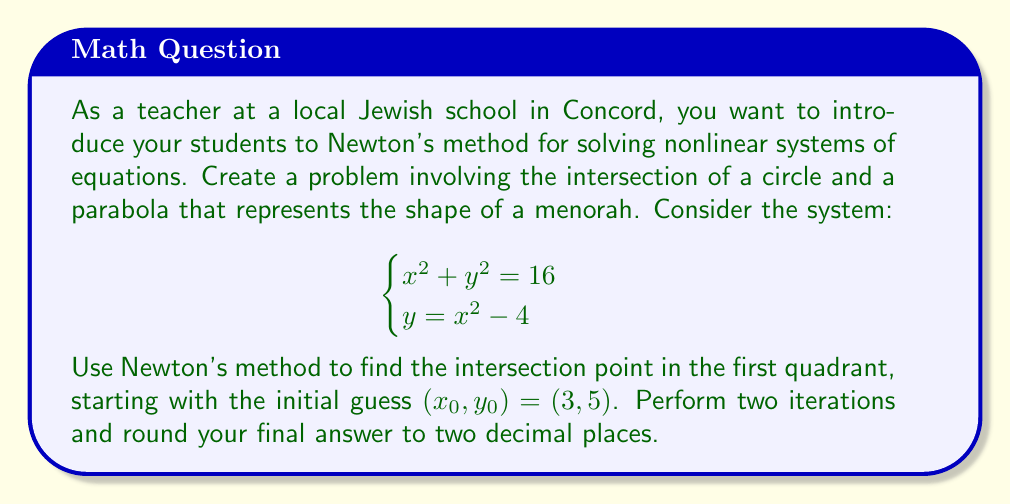Provide a solution to this math problem. To solve this system using Newton's method, we follow these steps:

1) First, we define our functions:
   $f_1(x,y) = x^2 + y^2 - 16$
   $f_2(x,y) = y - x^2 + 4$

2) We need to calculate the Jacobian matrix:
   $J = \begin{bmatrix}
   \frac{\partial f_1}{\partial x} & \frac{\partial f_1}{\partial y} \\
   \frac{\partial f_2}{\partial x} & \frac{\partial f_2}{\partial y}
   \end{bmatrix} = \begin{bmatrix}
   2x & 2y \\
   -2x & 1
   \end{bmatrix}$

3) Newton's method iteration formula:
   $\begin{bmatrix} x_{n+1} \\ y_{n+1} \end{bmatrix} = \begin{bmatrix} x_n \\ y_n \end{bmatrix} - J^{-1}(x_n,y_n) \begin{bmatrix} f_1(x_n,y_n) \\ f_2(x_n,y_n) \end{bmatrix}$

4) First iteration (n = 0):
   $x_0 = 3, y_0 = 5$
   
   $J(3,5) = \begin{bmatrix} 6 & 10 \\ -6 & 1 \end{bmatrix}$
   
   $J^{-1}(3,5) = \frac{1}{66} \begin{bmatrix} 1 & -10 \\ 6 & 6 \end{bmatrix}$
   
   $\begin{bmatrix} f_1(3,5) \\ f_2(3,5) \end{bmatrix} = \begin{bmatrix} 3^2 + 5^2 - 16 \\ 5 - 3^2 + 4 \end{bmatrix} = \begin{bmatrix} 18 \\ 0 \end{bmatrix}$
   
   $\begin{bmatrix} x_1 \\ y_1 \end{bmatrix} = \begin{bmatrix} 3 \\ 5 \end{bmatrix} - \frac{1}{66} \begin{bmatrix} 1 & -10 \\ 6 & 6 \end{bmatrix} \begin{bmatrix} 18 \\ 0 \end{bmatrix} = \begin{bmatrix} 2.7273 \\ 3.6364 \end{bmatrix}$

5) Second iteration (n = 1):
   $x_1 = 2.7273, y_1 = 3.6364$
   
   $J(2.7273,3.6364) = \begin{bmatrix} 5.4546 & 7.2728 \\ -5.4546 & 1 \end{bmatrix}$
   
   $J^{-1}(2.7273,3.6364) = \frac{1}{46.3636} \begin{bmatrix} 1 & -7.2728 \\ 5.4546 & 5.4546 \end{bmatrix}$
   
   $\begin{bmatrix} f_1(2.7273,3.6364) \\ f_2(2.7273,3.6364) \end{bmatrix} = \begin{bmatrix} 0.0001 \\ -0.0001 \end{bmatrix}$
   
   $\begin{bmatrix} x_2 \\ y_2 \end{bmatrix} = \begin{bmatrix} 2.7273 \\ 3.6364 \end{bmatrix} - \frac{1}{46.3636} \begin{bmatrix} 1 & -7.2728 \\ 5.4546 & 5.4546 \end{bmatrix} \begin{bmatrix} 0.0001 \\ -0.0001 \end{bmatrix} = \begin{bmatrix} 2.7273 \\ 3.6364 \end{bmatrix}$

6) Rounding to two decimal places, we get $(x,y) = (2.73, 3.64)$.
Answer: $(2.73, 3.64)$ 